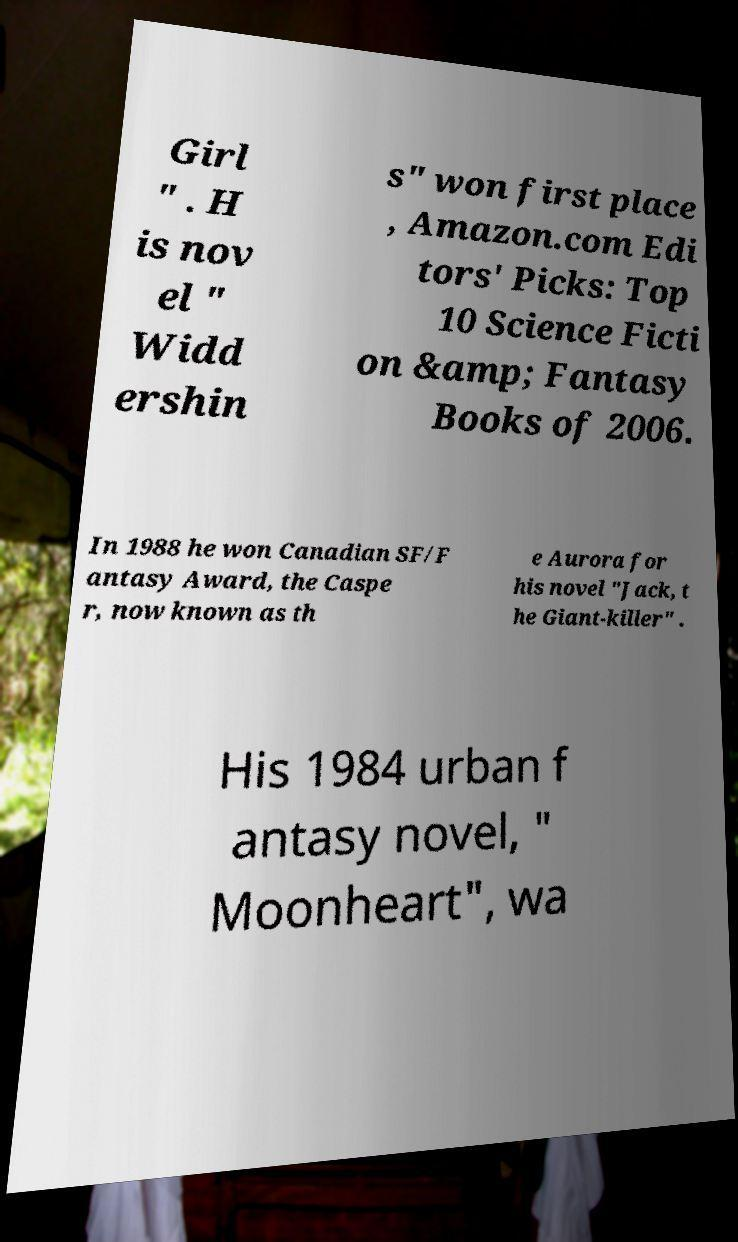What messages or text are displayed in this image? I need them in a readable, typed format. Girl " . H is nov el " Widd ershin s" won first place , Amazon.com Edi tors' Picks: Top 10 Science Ficti on &amp; Fantasy Books of 2006. In 1988 he won Canadian SF/F antasy Award, the Caspe r, now known as th e Aurora for his novel "Jack, t he Giant-killer" . His 1984 urban f antasy novel, " Moonheart", wa 